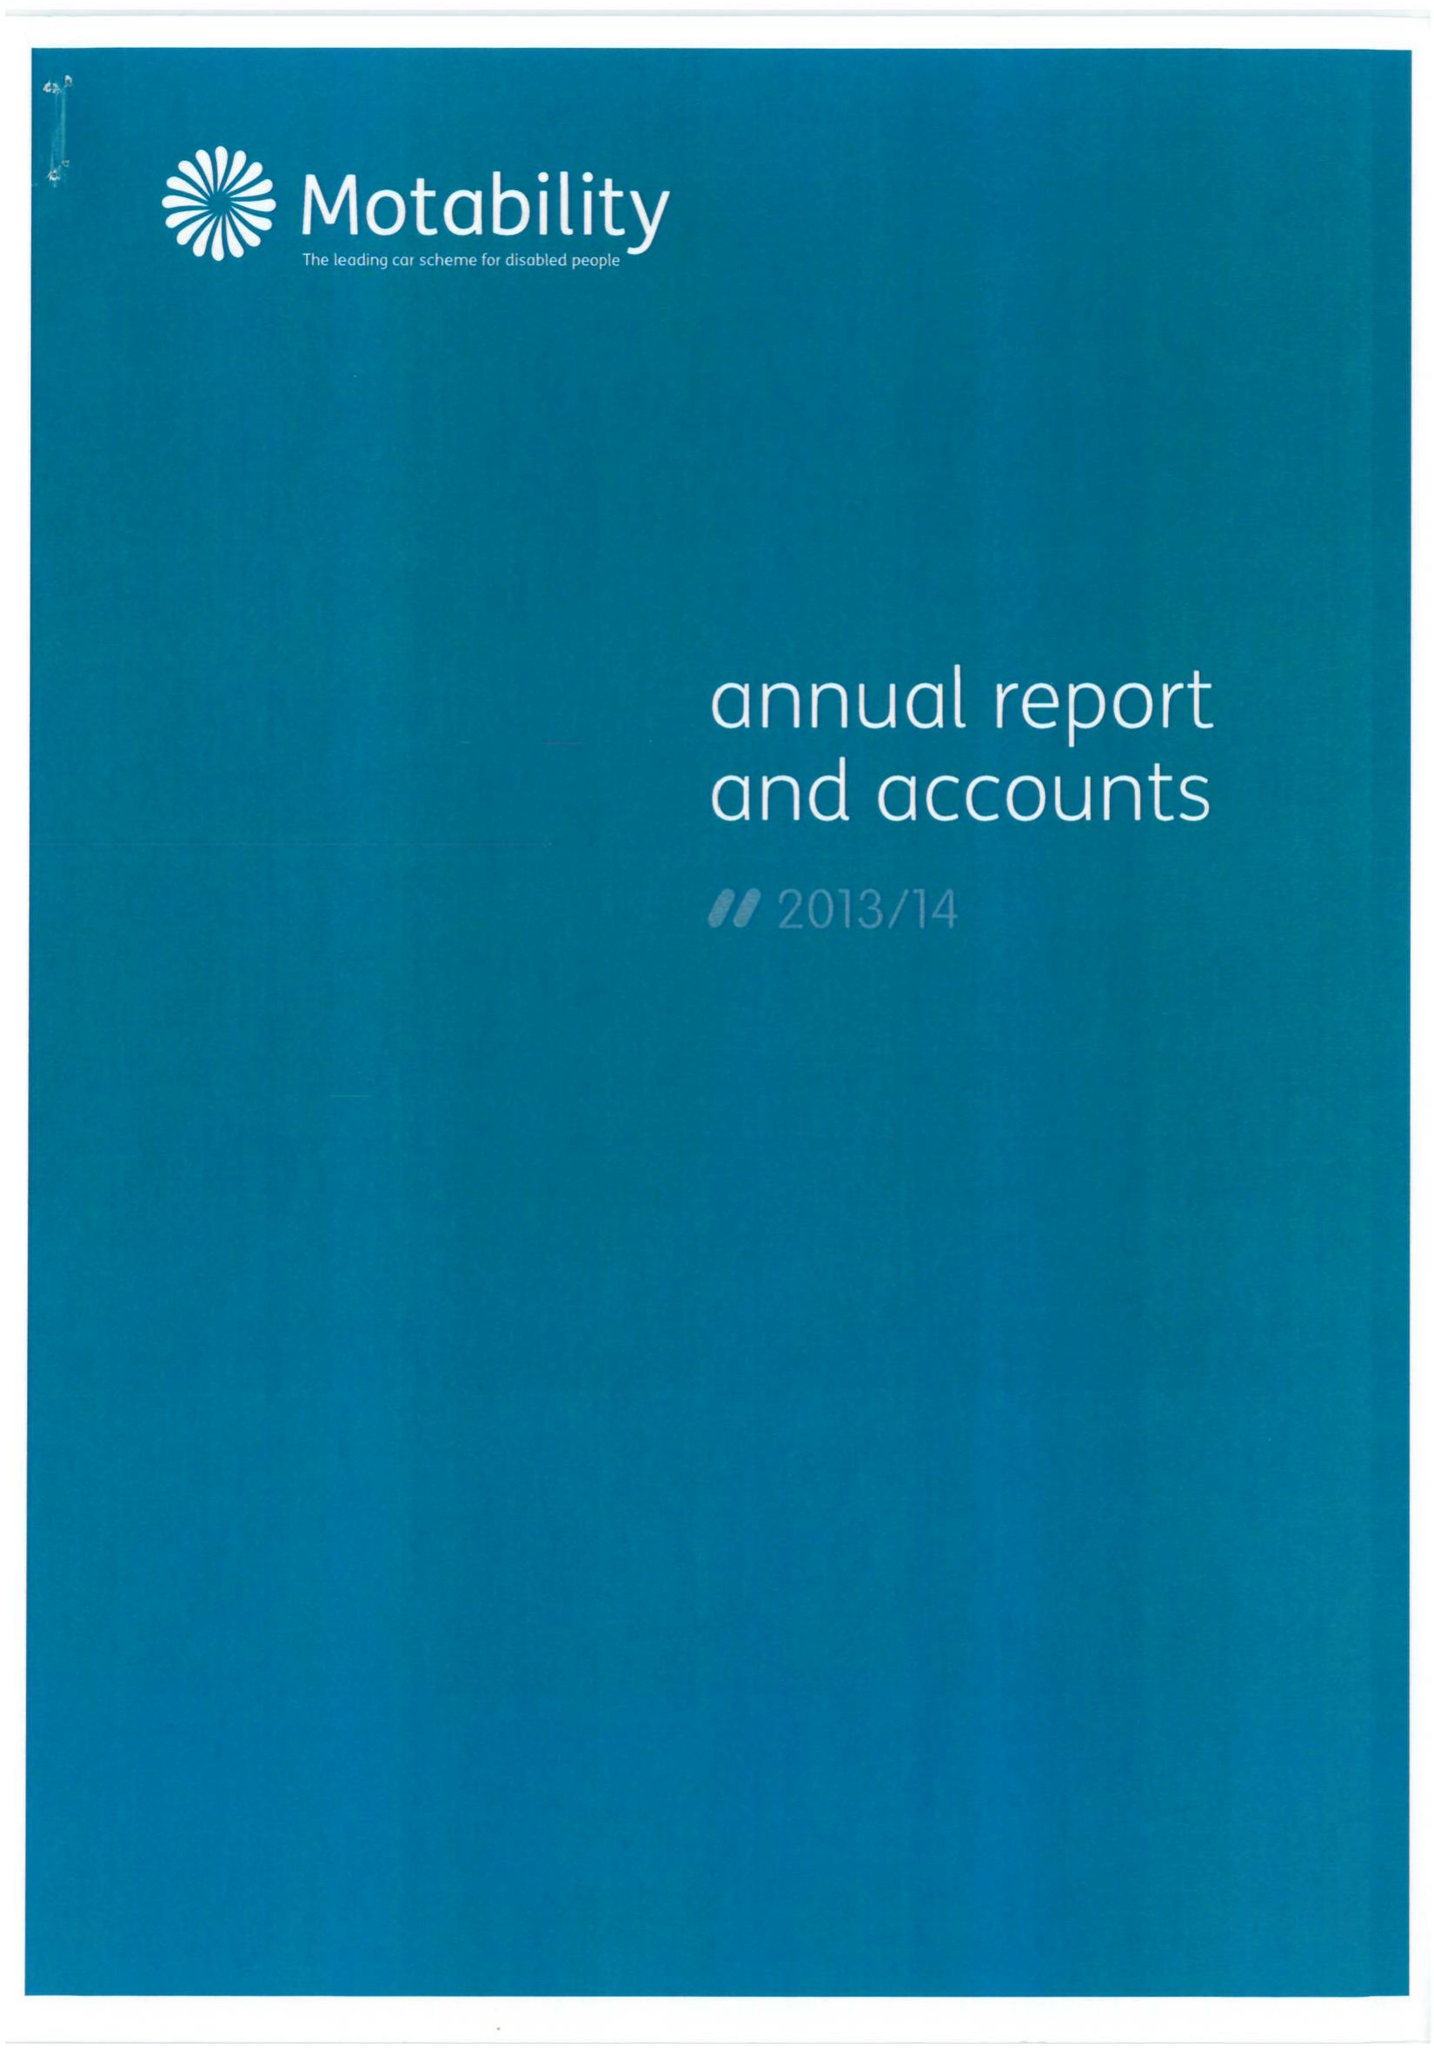What is the value for the charity_name?
Answer the question using a single word or phrase. Motability 